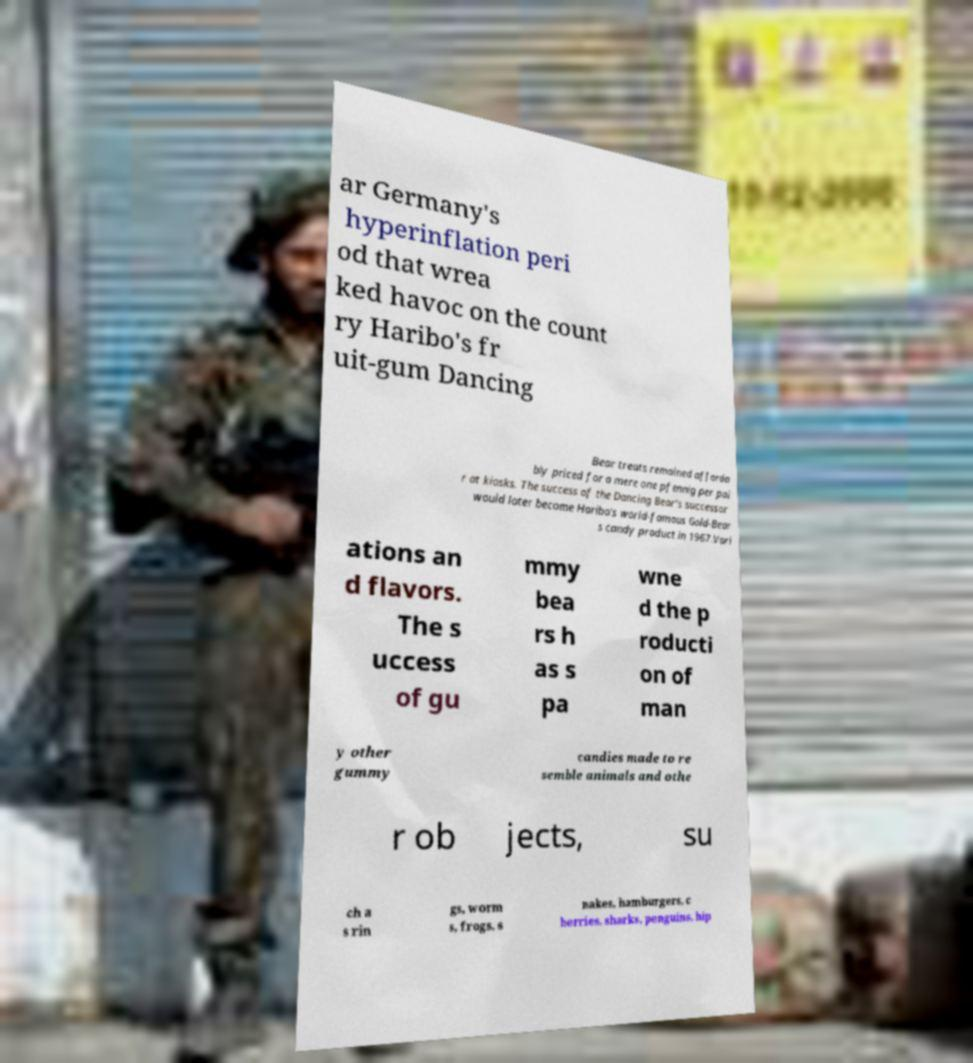Could you assist in decoding the text presented in this image and type it out clearly? ar Germany's hyperinflation peri od that wrea ked havoc on the count ry Haribo's fr uit-gum Dancing Bear treats remained afforda bly priced for a mere one pfennig per pai r at kiosks. The success of the Dancing Bear's successor would later become Haribo's world-famous Gold-Bear s candy product in 1967.Vari ations an d flavors. The s uccess of gu mmy bea rs h as s pa wne d the p roducti on of man y other gummy candies made to re semble animals and othe r ob jects, su ch a s rin gs, worm s, frogs, s nakes, hamburgers, c herries, sharks, penguins, hip 